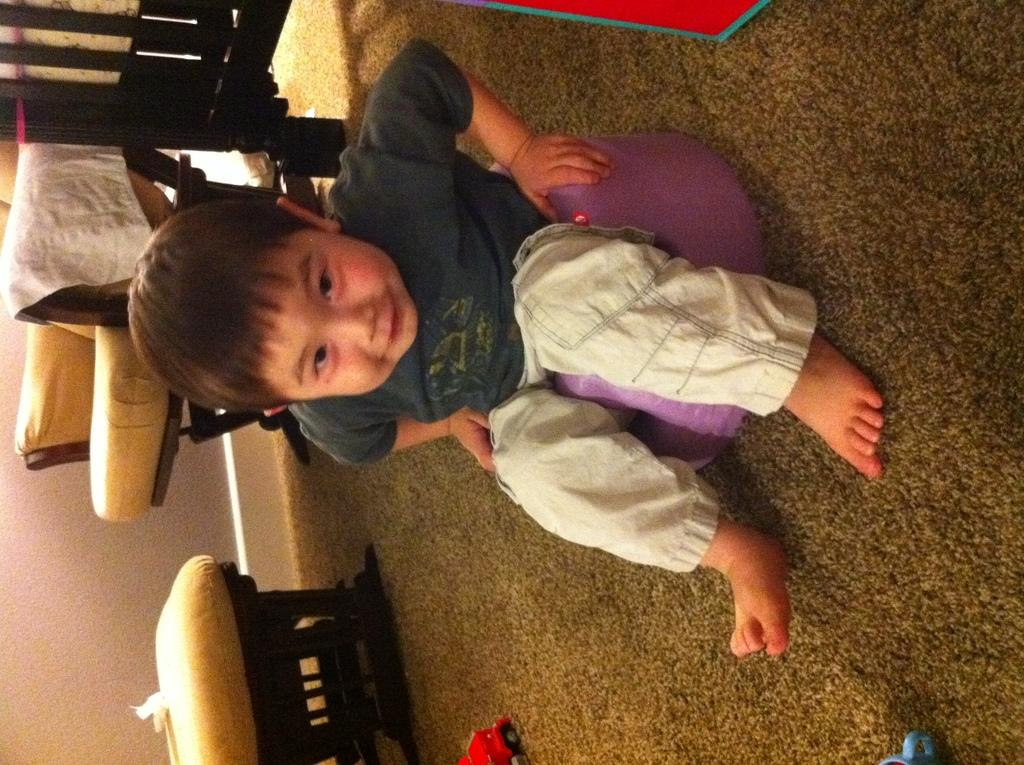Who is the main subject in the image? There is a small boy in the image. What is the boy sitting on? The boy is sitting on a purple stool. What is the boy doing in the image? The boy is looking into the camera. What can be seen in the background of the image? There are wooden chairs and a cushion table in the background. What type of bun is the boy holding in the image? There is no bun present in the image; the boy is not holding any food item. 